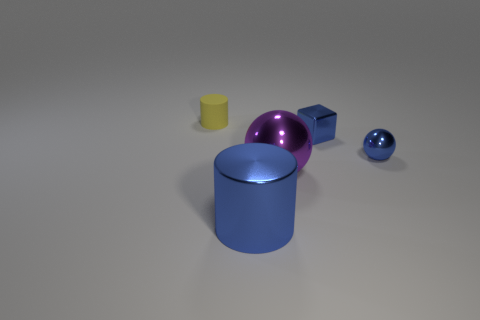Add 1 small purple rubber balls. How many objects exist? 6 Subtract all balls. How many objects are left? 3 Subtract 0 cyan spheres. How many objects are left? 5 Subtract 1 cubes. How many cubes are left? 0 Subtract all brown cylinders. Subtract all green cubes. How many cylinders are left? 2 Subtract all purple spheres. How many cyan blocks are left? 0 Subtract all cylinders. Subtract all blue shiny spheres. How many objects are left? 2 Add 3 small blue metal blocks. How many small blue metal blocks are left? 4 Add 3 tiny metallic objects. How many tiny metallic objects exist? 5 